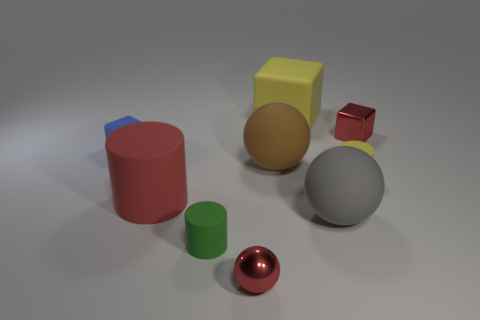What shape is the red shiny thing right of the metallic object in front of the small blue rubber cube that is behind the large brown rubber thing? The red shiny object to the right of the metallic sphere, situated in front of the small blue rubber cube and behind the large brown rubber cylinder, is a sphere. 